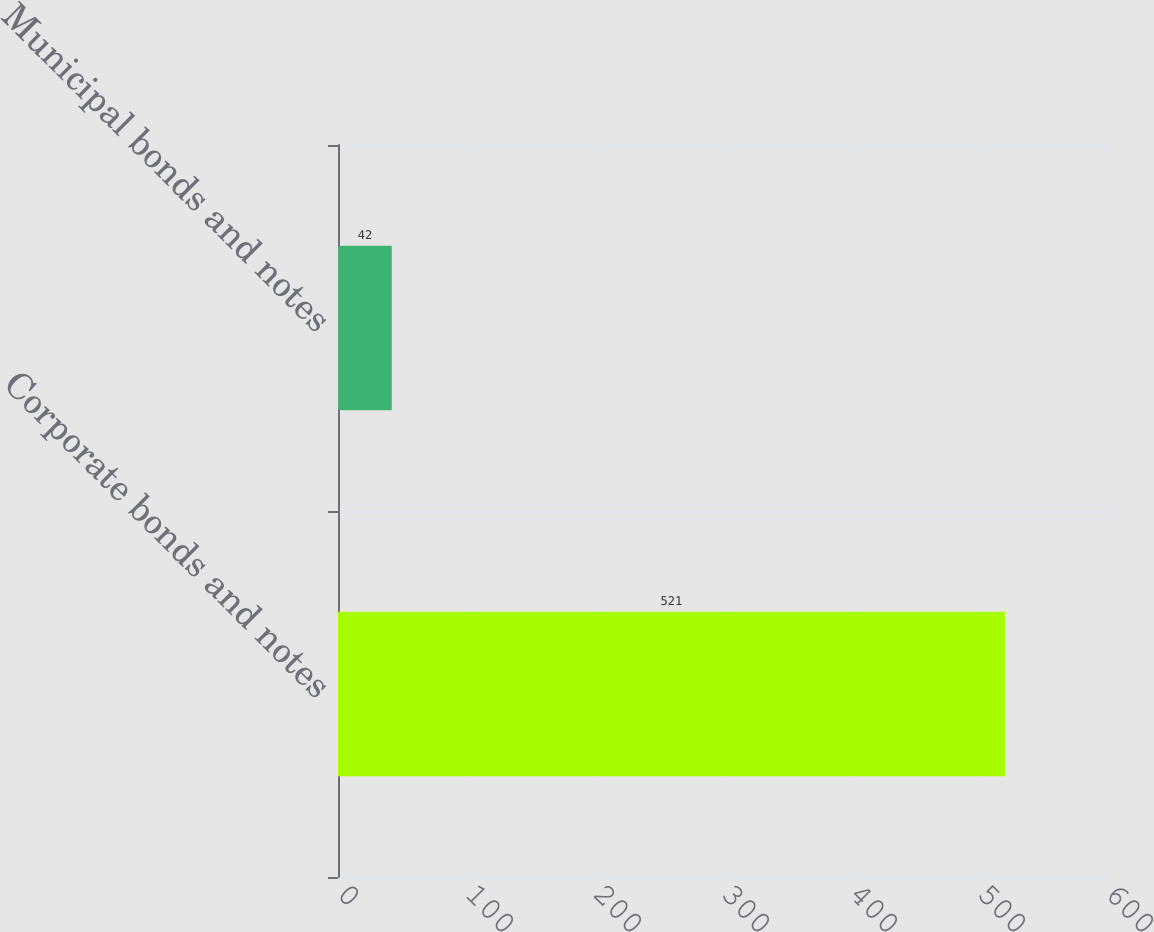Convert chart to OTSL. <chart><loc_0><loc_0><loc_500><loc_500><bar_chart><fcel>Corporate bonds and notes<fcel>Municipal bonds and notes<nl><fcel>521<fcel>42<nl></chart> 